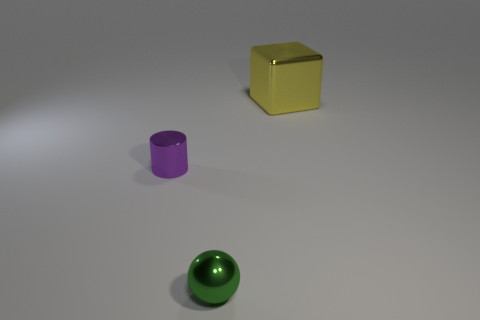The metallic thing that is on the left side of the big metallic block and to the right of the tiny purple cylinder is what color?
Keep it short and to the point. Green. Is the number of green metallic things greater than the number of tiny green shiny blocks?
Keep it short and to the point. Yes. What number of things are yellow spheres or small objects that are in front of the small purple cylinder?
Offer a very short reply. 1. Do the metal ball and the shiny cube have the same size?
Give a very brief answer. No. Are there any small purple metallic cylinders right of the small green object?
Provide a short and direct response. No. There is a object that is both on the left side of the metal block and right of the metallic cylinder; what size is it?
Make the answer very short. Small. How many things are small things or red things?
Offer a very short reply. 2. Does the purple thing have the same size as the object to the right of the tiny sphere?
Ensure brevity in your answer.  No. What size is the shiny thing that is on the right side of the small object in front of the thing left of the tiny green sphere?
Provide a short and direct response. Large. Are there any small purple cylinders?
Provide a short and direct response. Yes. 